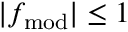Convert formula to latex. <formula><loc_0><loc_0><loc_500><loc_500>| f _ { m o d } | \leq 1</formula> 